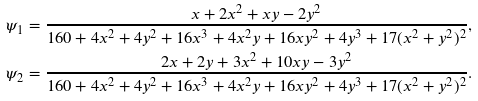<formula> <loc_0><loc_0><loc_500><loc_500>\psi _ { 1 } = \frac { x + 2 x ^ { 2 } + x y - 2 y ^ { 2 } } { 1 6 0 + 4 x ^ { 2 } + 4 y ^ { 2 } + 1 6 x ^ { 3 } + 4 x ^ { 2 } y + 1 6 x y ^ { 2 } + 4 y ^ { 3 } + 1 7 ( x ^ { 2 } + y ^ { 2 } ) ^ { 2 } } , \\ \psi _ { 2 } = \frac { 2 x + 2 y + 3 x ^ { 2 } + 1 0 x y - 3 y ^ { 2 } } { 1 6 0 + 4 x ^ { 2 } + 4 y ^ { 2 } + 1 6 x ^ { 3 } + 4 x ^ { 2 } y + 1 6 x y ^ { 2 } + 4 y ^ { 3 } + 1 7 ( x ^ { 2 } + y ^ { 2 } ) ^ { 2 } } .</formula> 